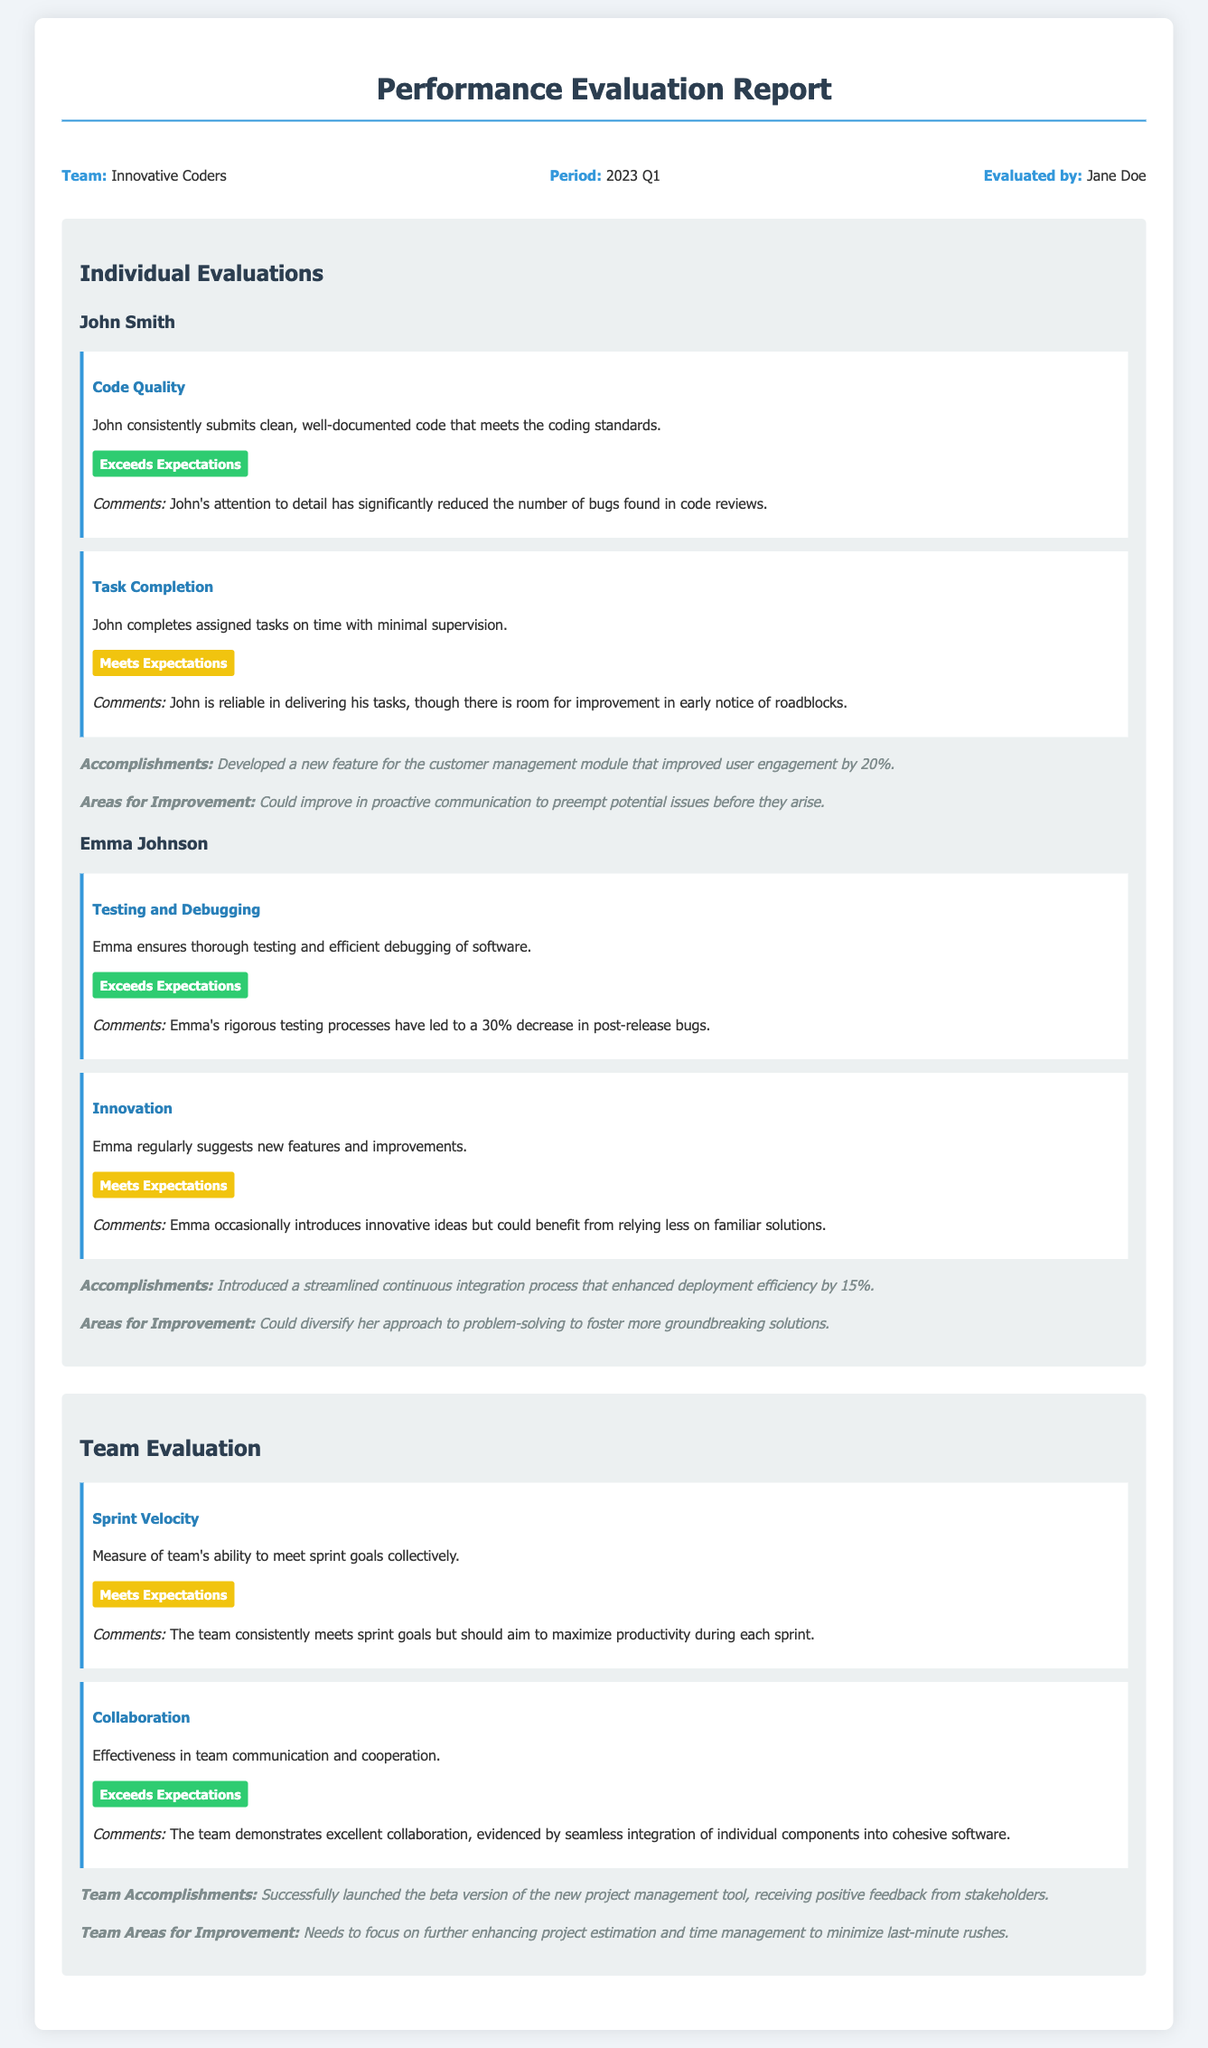What is the name of the team evaluated? The name of the team evaluated is mentioned in the document's header section under "Team:".
Answer: Innovative Coders Who evaluated the performance? The evaluator's name is provided in the document under "Evaluated by:".
Answer: Jane Doe What is John's accomplishment? John's specific accomplishment is listed in the individual evaluation section.
Answer: Developed a new feature for the customer management module that improved user engagement by 20% What rating did Emma receive for Testing and Debugging? The rating for Emma's performance in Testing and Debugging is stated in her individual evaluation.
Answer: Exceeds Expectations What area for improvement is noted for the team? The areas for improvement for the team are provided in the team evaluation section.
Answer: Needs to focus on further enhancing project estimation and time management to minimize last-minute rushes How did the team perform in terms of Sprint Velocity? The team's performance in Sprint Velocity is directly stated in the team evaluation section.
Answer: Meets Expectations What percentage decrease in post-release bugs did Emma's testing processes lead to? The document specifies the percentage decrease in post-release bugs resulting from Emma's efforts.
Answer: 30% Which KPI did John meet expectations in? The specific KPI where John's performance met expectations is listed in his individual evaluation results.
Answer: Task Completion 